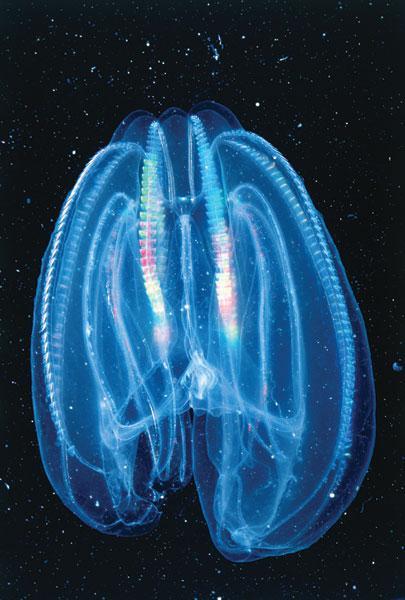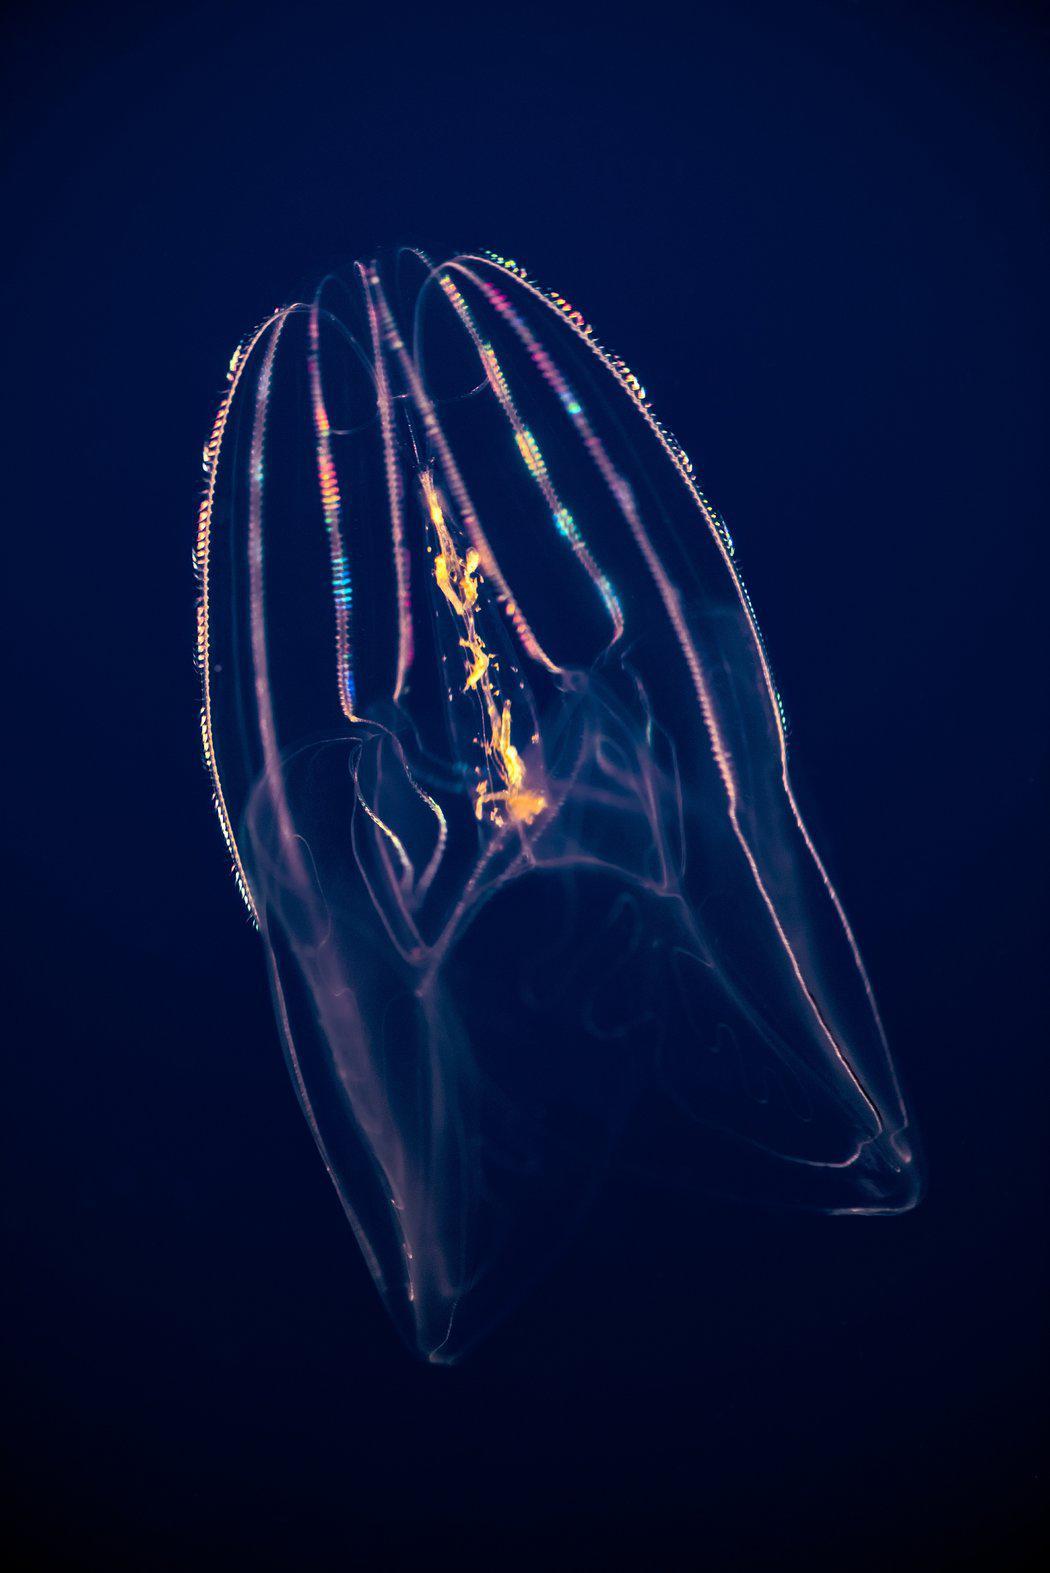The first image is the image on the left, the second image is the image on the right. Evaluate the accuracy of this statement regarding the images: "Both images show jellyfish with trailing tentacles.". Is it true? Answer yes or no. No. 